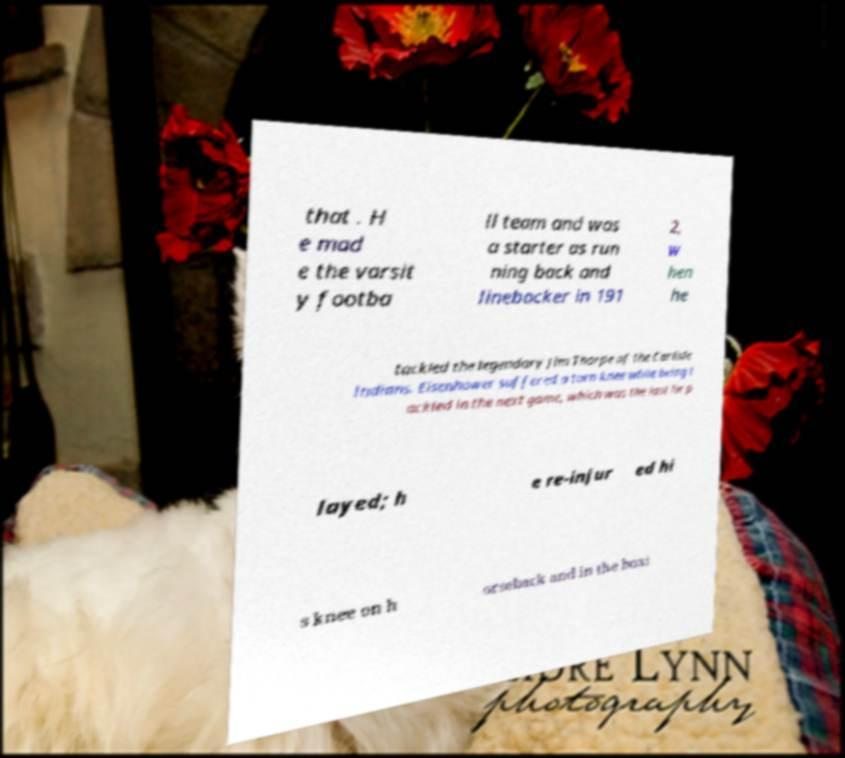Could you assist in decoding the text presented in this image and type it out clearly? that . H e mad e the varsit y footba ll team and was a starter as run ning back and linebacker in 191 2, w hen he tackled the legendary Jim Thorpe of the Carlisle Indians. Eisenhower suffered a torn knee while being t ackled in the next game, which was the last he p layed; h e re-injur ed hi s knee on h orseback and in the boxi 